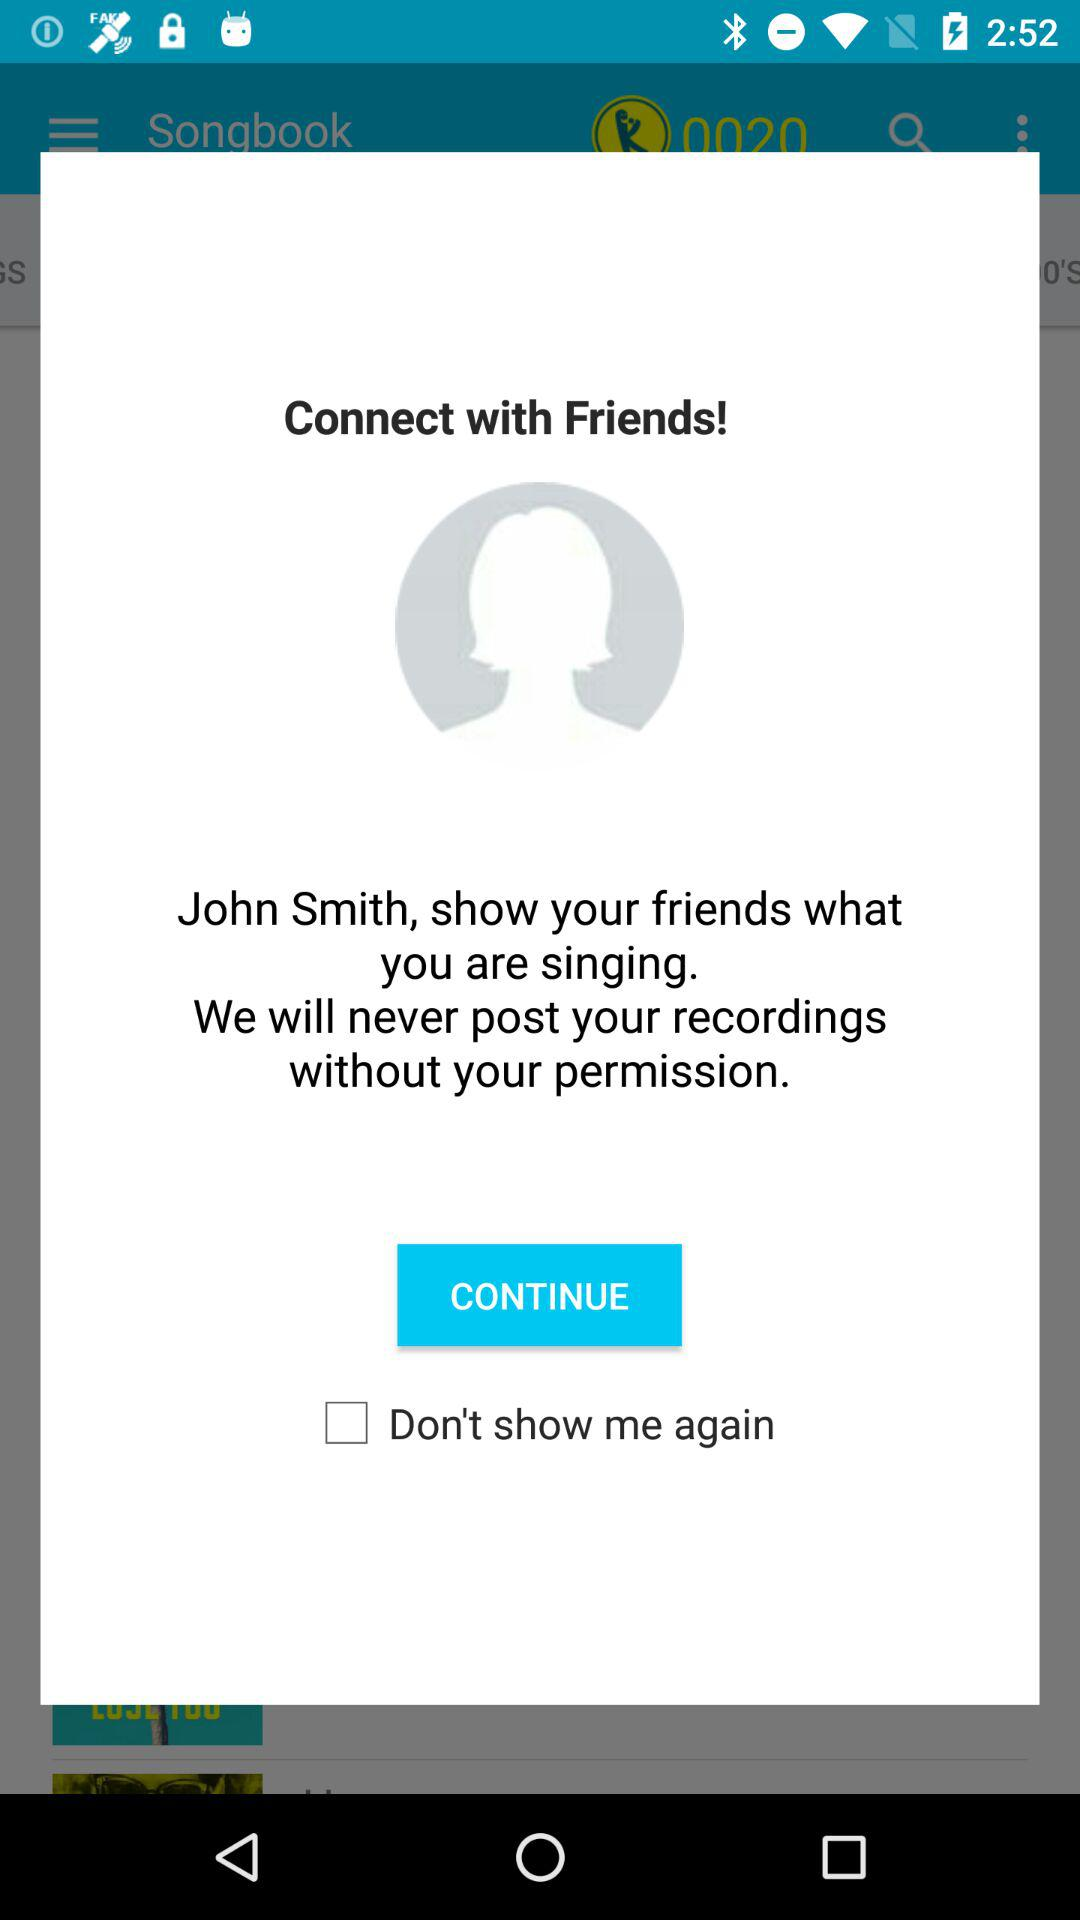What is the user name? The user name is John Smith. 